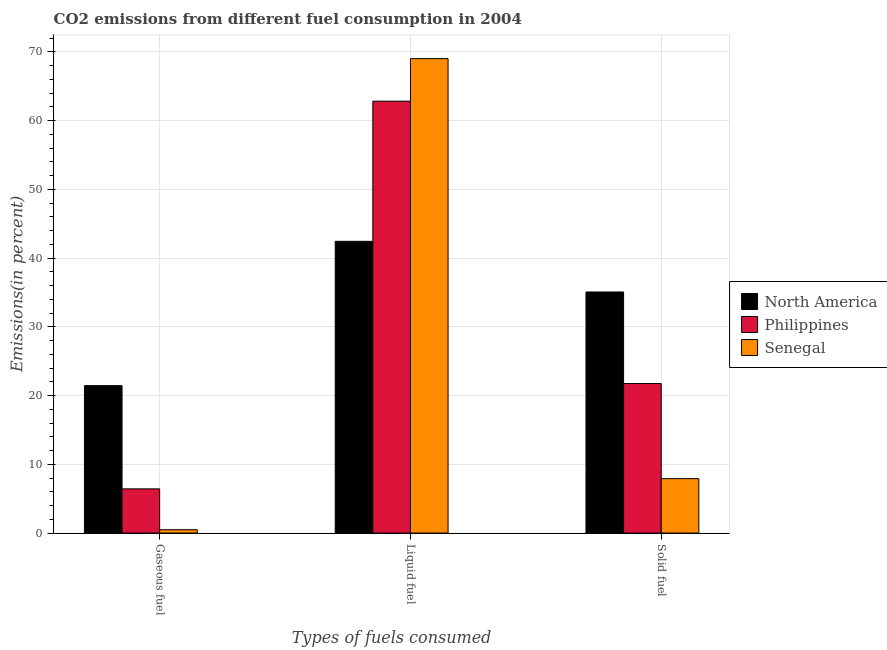How many groups of bars are there?
Give a very brief answer. 3. How many bars are there on the 3rd tick from the right?
Provide a short and direct response. 3. What is the label of the 1st group of bars from the left?
Make the answer very short. Gaseous fuel. What is the percentage of liquid fuel emission in North America?
Give a very brief answer. 42.45. Across all countries, what is the maximum percentage of gaseous fuel emission?
Ensure brevity in your answer.  21.45. Across all countries, what is the minimum percentage of solid fuel emission?
Offer a terse response. 7.92. In which country was the percentage of gaseous fuel emission maximum?
Provide a succinct answer. North America. In which country was the percentage of solid fuel emission minimum?
Your answer should be compact. Senegal. What is the total percentage of solid fuel emission in the graph?
Your answer should be very brief. 64.74. What is the difference between the percentage of liquid fuel emission in North America and that in Philippines?
Offer a very short reply. -20.39. What is the difference between the percentage of solid fuel emission in North America and the percentage of gaseous fuel emission in Senegal?
Your response must be concise. 34.59. What is the average percentage of liquid fuel emission per country?
Keep it short and to the point. 58.1. What is the difference between the percentage of solid fuel emission and percentage of liquid fuel emission in North America?
Offer a very short reply. -7.37. What is the ratio of the percentage of gaseous fuel emission in Philippines to that in North America?
Your answer should be very brief. 0.3. Is the percentage of gaseous fuel emission in North America less than that in Senegal?
Provide a short and direct response. No. Is the difference between the percentage of gaseous fuel emission in Senegal and North America greater than the difference between the percentage of liquid fuel emission in Senegal and North America?
Give a very brief answer. No. What is the difference between the highest and the second highest percentage of solid fuel emission?
Ensure brevity in your answer.  13.32. What is the difference between the highest and the lowest percentage of gaseous fuel emission?
Keep it short and to the point. 20.96. In how many countries, is the percentage of liquid fuel emission greater than the average percentage of liquid fuel emission taken over all countries?
Give a very brief answer. 2. What does the 3rd bar from the left in Solid fuel represents?
Make the answer very short. Senegal. How many bars are there?
Your response must be concise. 9. Are all the bars in the graph horizontal?
Make the answer very short. No. How many countries are there in the graph?
Provide a succinct answer. 3. Are the values on the major ticks of Y-axis written in scientific E-notation?
Your answer should be compact. No. Does the graph contain any zero values?
Provide a short and direct response. No. Does the graph contain grids?
Your answer should be very brief. Yes. Where does the legend appear in the graph?
Your response must be concise. Center right. How many legend labels are there?
Your answer should be compact. 3. How are the legend labels stacked?
Give a very brief answer. Vertical. What is the title of the graph?
Provide a succinct answer. CO2 emissions from different fuel consumption in 2004. What is the label or title of the X-axis?
Offer a very short reply. Types of fuels consumed. What is the label or title of the Y-axis?
Keep it short and to the point. Emissions(in percent). What is the Emissions(in percent) of North America in Gaseous fuel?
Provide a short and direct response. 21.45. What is the Emissions(in percent) of Philippines in Gaseous fuel?
Your answer should be very brief. 6.43. What is the Emissions(in percent) in Senegal in Gaseous fuel?
Give a very brief answer. 0.49. What is the Emissions(in percent) in North America in Liquid fuel?
Provide a short and direct response. 42.45. What is the Emissions(in percent) of Philippines in Liquid fuel?
Give a very brief answer. 62.83. What is the Emissions(in percent) in Senegal in Liquid fuel?
Keep it short and to the point. 69.03. What is the Emissions(in percent) of North America in Solid fuel?
Give a very brief answer. 35.07. What is the Emissions(in percent) of Philippines in Solid fuel?
Your answer should be very brief. 21.75. What is the Emissions(in percent) in Senegal in Solid fuel?
Provide a succinct answer. 7.92. Across all Types of fuels consumed, what is the maximum Emissions(in percent) of North America?
Keep it short and to the point. 42.45. Across all Types of fuels consumed, what is the maximum Emissions(in percent) of Philippines?
Ensure brevity in your answer.  62.83. Across all Types of fuels consumed, what is the maximum Emissions(in percent) of Senegal?
Offer a terse response. 69.03. Across all Types of fuels consumed, what is the minimum Emissions(in percent) in North America?
Offer a terse response. 21.45. Across all Types of fuels consumed, what is the minimum Emissions(in percent) of Philippines?
Your answer should be very brief. 6.43. Across all Types of fuels consumed, what is the minimum Emissions(in percent) in Senegal?
Offer a very short reply. 0.49. What is the total Emissions(in percent) in North America in the graph?
Offer a very short reply. 98.97. What is the total Emissions(in percent) in Philippines in the graph?
Offer a terse response. 91.02. What is the total Emissions(in percent) in Senegal in the graph?
Your response must be concise. 77.43. What is the difference between the Emissions(in percent) of North America in Gaseous fuel and that in Liquid fuel?
Your answer should be very brief. -21. What is the difference between the Emissions(in percent) of Philippines in Gaseous fuel and that in Liquid fuel?
Your response must be concise. -56.4. What is the difference between the Emissions(in percent) of Senegal in Gaseous fuel and that in Liquid fuel?
Make the answer very short. -68.54. What is the difference between the Emissions(in percent) of North America in Gaseous fuel and that in Solid fuel?
Make the answer very short. -13.62. What is the difference between the Emissions(in percent) in Philippines in Gaseous fuel and that in Solid fuel?
Ensure brevity in your answer.  -15.32. What is the difference between the Emissions(in percent) of Senegal in Gaseous fuel and that in Solid fuel?
Offer a terse response. -7.43. What is the difference between the Emissions(in percent) in North America in Liquid fuel and that in Solid fuel?
Keep it short and to the point. 7.37. What is the difference between the Emissions(in percent) in Philippines in Liquid fuel and that in Solid fuel?
Your answer should be very brief. 41.08. What is the difference between the Emissions(in percent) in Senegal in Liquid fuel and that in Solid fuel?
Give a very brief answer. 61.11. What is the difference between the Emissions(in percent) in North America in Gaseous fuel and the Emissions(in percent) in Philippines in Liquid fuel?
Provide a succinct answer. -41.38. What is the difference between the Emissions(in percent) in North America in Gaseous fuel and the Emissions(in percent) in Senegal in Liquid fuel?
Keep it short and to the point. -47.58. What is the difference between the Emissions(in percent) of Philippines in Gaseous fuel and the Emissions(in percent) of Senegal in Liquid fuel?
Ensure brevity in your answer.  -62.6. What is the difference between the Emissions(in percent) in North America in Gaseous fuel and the Emissions(in percent) in Philippines in Solid fuel?
Offer a terse response. -0.31. What is the difference between the Emissions(in percent) in North America in Gaseous fuel and the Emissions(in percent) in Senegal in Solid fuel?
Ensure brevity in your answer.  13.53. What is the difference between the Emissions(in percent) in Philippines in Gaseous fuel and the Emissions(in percent) in Senegal in Solid fuel?
Provide a short and direct response. -1.49. What is the difference between the Emissions(in percent) in North America in Liquid fuel and the Emissions(in percent) in Philippines in Solid fuel?
Your answer should be very brief. 20.69. What is the difference between the Emissions(in percent) of North America in Liquid fuel and the Emissions(in percent) of Senegal in Solid fuel?
Offer a very short reply. 34.53. What is the difference between the Emissions(in percent) of Philippines in Liquid fuel and the Emissions(in percent) of Senegal in Solid fuel?
Offer a terse response. 54.92. What is the average Emissions(in percent) in North America per Types of fuels consumed?
Your response must be concise. 32.99. What is the average Emissions(in percent) in Philippines per Types of fuels consumed?
Offer a very short reply. 30.34. What is the average Emissions(in percent) in Senegal per Types of fuels consumed?
Ensure brevity in your answer.  25.81. What is the difference between the Emissions(in percent) in North America and Emissions(in percent) in Philippines in Gaseous fuel?
Offer a terse response. 15.02. What is the difference between the Emissions(in percent) of North America and Emissions(in percent) of Senegal in Gaseous fuel?
Offer a terse response. 20.96. What is the difference between the Emissions(in percent) of Philippines and Emissions(in percent) of Senegal in Gaseous fuel?
Offer a very short reply. 5.95. What is the difference between the Emissions(in percent) in North America and Emissions(in percent) in Philippines in Liquid fuel?
Keep it short and to the point. -20.39. What is the difference between the Emissions(in percent) of North America and Emissions(in percent) of Senegal in Liquid fuel?
Provide a short and direct response. -26.58. What is the difference between the Emissions(in percent) in Philippines and Emissions(in percent) in Senegal in Liquid fuel?
Give a very brief answer. -6.19. What is the difference between the Emissions(in percent) in North America and Emissions(in percent) in Philippines in Solid fuel?
Offer a very short reply. 13.32. What is the difference between the Emissions(in percent) of North America and Emissions(in percent) of Senegal in Solid fuel?
Provide a succinct answer. 27.16. What is the difference between the Emissions(in percent) in Philippines and Emissions(in percent) in Senegal in Solid fuel?
Make the answer very short. 13.84. What is the ratio of the Emissions(in percent) of North America in Gaseous fuel to that in Liquid fuel?
Keep it short and to the point. 0.51. What is the ratio of the Emissions(in percent) in Philippines in Gaseous fuel to that in Liquid fuel?
Your answer should be very brief. 0.1. What is the ratio of the Emissions(in percent) of Senegal in Gaseous fuel to that in Liquid fuel?
Give a very brief answer. 0.01. What is the ratio of the Emissions(in percent) in North America in Gaseous fuel to that in Solid fuel?
Your answer should be compact. 0.61. What is the ratio of the Emissions(in percent) in Philippines in Gaseous fuel to that in Solid fuel?
Give a very brief answer. 0.3. What is the ratio of the Emissions(in percent) in Senegal in Gaseous fuel to that in Solid fuel?
Ensure brevity in your answer.  0.06. What is the ratio of the Emissions(in percent) of North America in Liquid fuel to that in Solid fuel?
Give a very brief answer. 1.21. What is the ratio of the Emissions(in percent) of Philippines in Liquid fuel to that in Solid fuel?
Provide a succinct answer. 2.89. What is the ratio of the Emissions(in percent) of Senegal in Liquid fuel to that in Solid fuel?
Your response must be concise. 8.72. What is the difference between the highest and the second highest Emissions(in percent) of North America?
Give a very brief answer. 7.37. What is the difference between the highest and the second highest Emissions(in percent) in Philippines?
Make the answer very short. 41.08. What is the difference between the highest and the second highest Emissions(in percent) of Senegal?
Your response must be concise. 61.11. What is the difference between the highest and the lowest Emissions(in percent) in North America?
Provide a short and direct response. 21. What is the difference between the highest and the lowest Emissions(in percent) of Philippines?
Offer a terse response. 56.4. What is the difference between the highest and the lowest Emissions(in percent) in Senegal?
Offer a terse response. 68.54. 